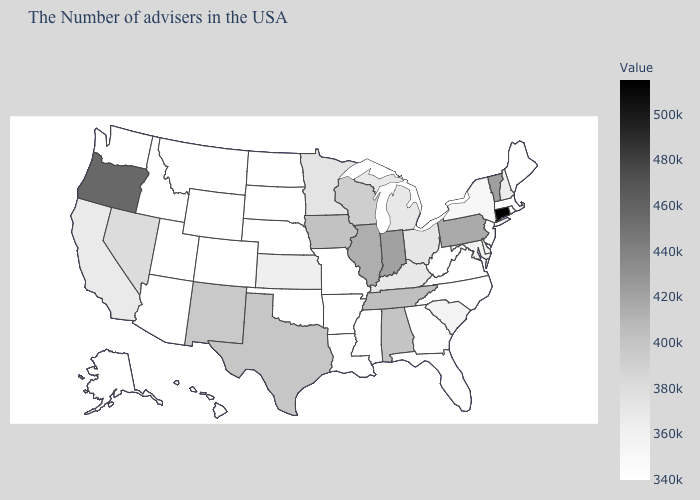Does Vermont have the lowest value in the USA?
Quick response, please. No. Among the states that border Vermont , does New Hampshire have the highest value?
Concise answer only. Yes. Does Connecticut have the highest value in the USA?
Write a very short answer. Yes. Does New Hampshire have the highest value in the Northeast?
Keep it brief. No. Does Maryland have a higher value than Nevada?
Write a very short answer. No. 